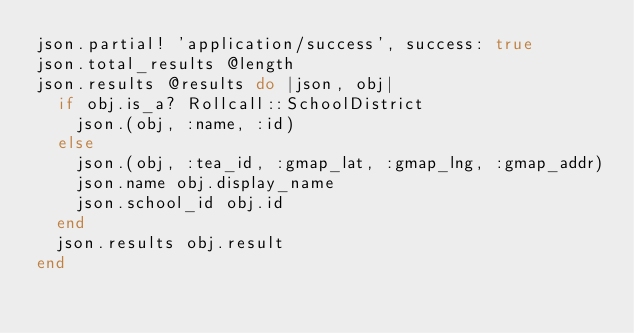Convert code to text. <code><loc_0><loc_0><loc_500><loc_500><_Ruby_>json.partial! 'application/success', success: true
json.total_results @length
json.results @results do |json, obj|  
  if obj.is_a? Rollcall::SchoolDistrict
    json.(obj, :name, :id)
  else
    json.(obj, :tea_id, :gmap_lat, :gmap_lng, :gmap_addr)
    json.name obj.display_name
    json.school_id obj.id
  end  
  json.results obj.result
end
</code> 